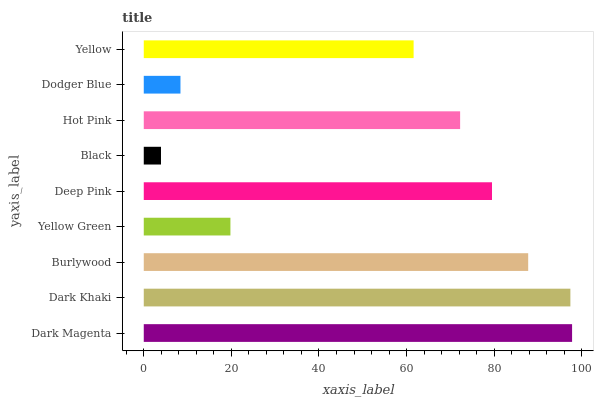Is Black the minimum?
Answer yes or no. Yes. Is Dark Magenta the maximum?
Answer yes or no. Yes. Is Dark Khaki the minimum?
Answer yes or no. No. Is Dark Khaki the maximum?
Answer yes or no. No. Is Dark Magenta greater than Dark Khaki?
Answer yes or no. Yes. Is Dark Khaki less than Dark Magenta?
Answer yes or no. Yes. Is Dark Khaki greater than Dark Magenta?
Answer yes or no. No. Is Dark Magenta less than Dark Khaki?
Answer yes or no. No. Is Hot Pink the high median?
Answer yes or no. Yes. Is Hot Pink the low median?
Answer yes or no. Yes. Is Yellow the high median?
Answer yes or no. No. Is Yellow the low median?
Answer yes or no. No. 